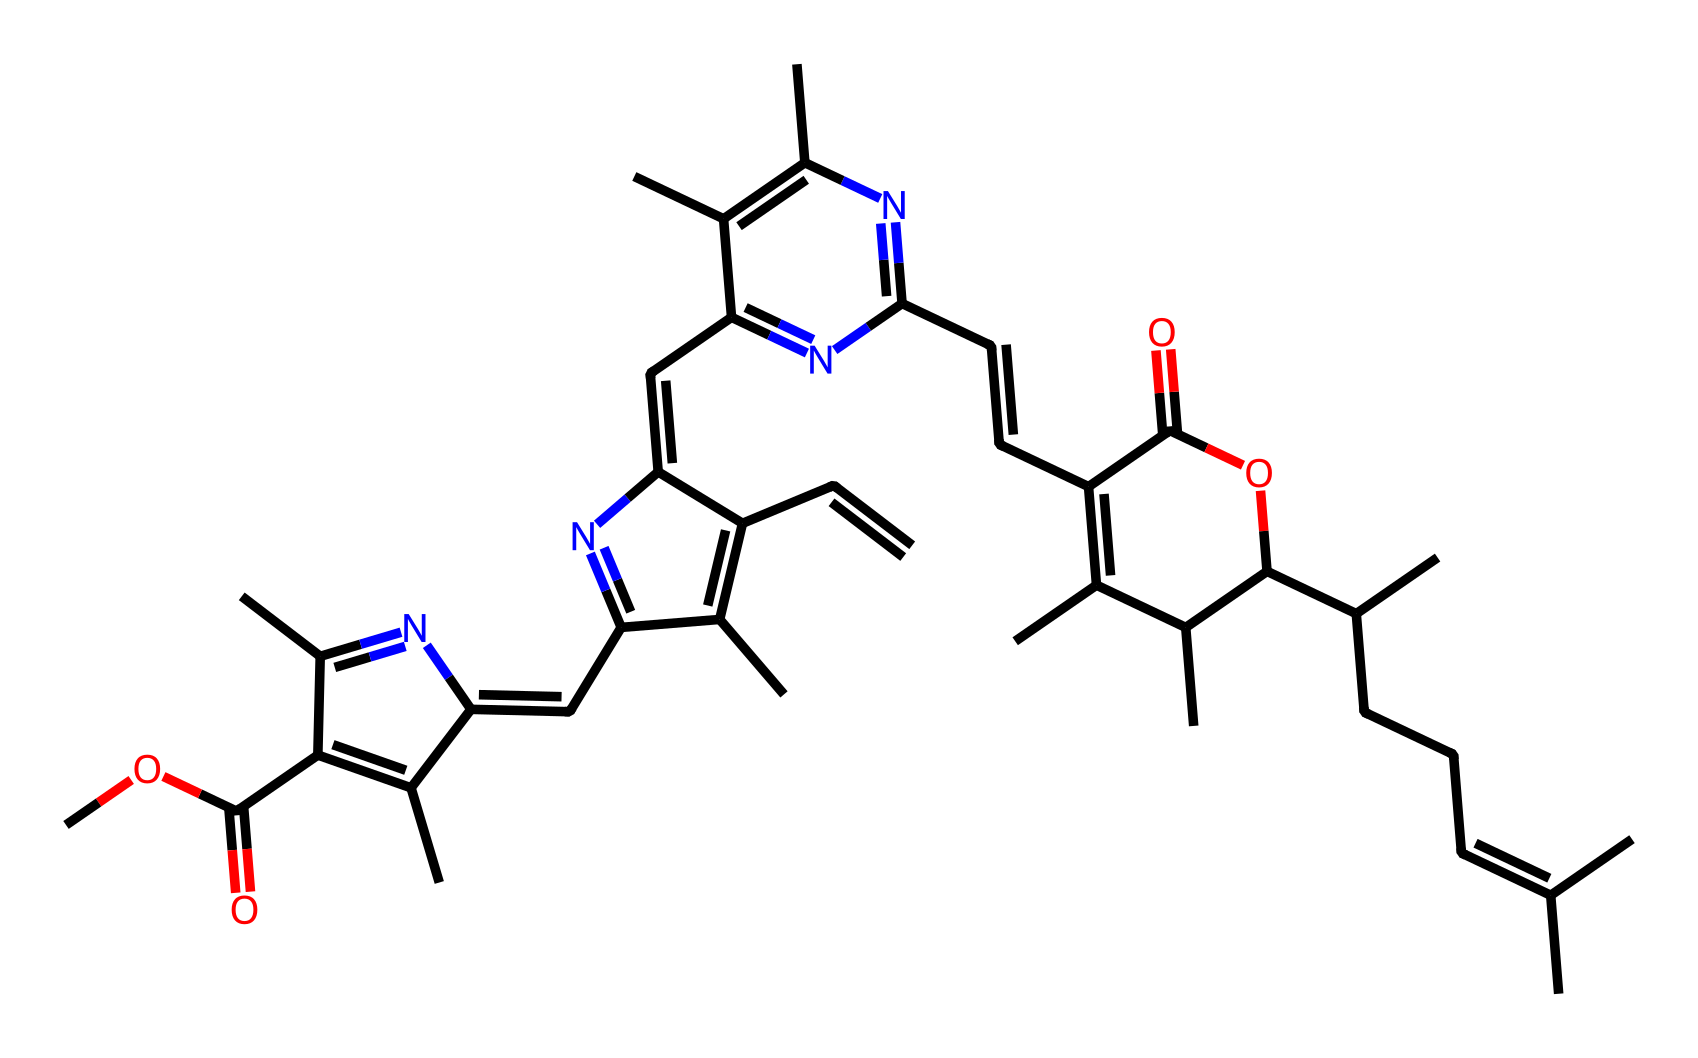How many carbon atoms are in the structure? By analyzing the SMILES representation, we can count the number of 'C' characters that represent carbon atoms. Each carbon atom in the structure signifies a point in the molecule, and in this case, a systematic count shows that there are 30 carbon atoms.
Answer: 30 What functional groups are present in this chemical? Looking at the structure derived from the SMILES, we can identify the functional groups by observing the atoms and their connections. Notably, there are ester groups (evidenced by the -OC(=O) linkage) and amine groups (indicated by the presence of nitrogen atoms attached to carbon chains).
Answer: ester, amine How many nitrogen atoms are in this molecule? By systematically reviewing the SMILES representation, we can identify and count the number of 'N' characters, each representing a nitrogen atom in the compound. In this molecule, there are 4 nitrogen atoms present.
Answer: 4 What is the type of organic compound represented by this SMILES? The structure suggests a porphyrin-like compound, a class of organic compounds characterized by a large, cyclic arrangement of carbon and nitrogen atoms. This specific structure aligns with the characteristics of chlorophyll.
Answer: porphyrin Which part of the chemical is responsible for light absorption? In chlorophyll molecules, the conjugated double bonds within the rings and the presence of a long hydrophobic tail are critical for absorbing light. These conjugated systems allow for electron delocalization, enhancing light absorption efficiency, especially in the visible range.
Answer: conjugated double bonds What does the presence of multiple nitrogen atoms indicate about this molecule? The multiple nitrogen atoms in the structure serve as ligands that coordinate with magnesium ions typically found in chlorophyll. This coordination is crucial for the stability of the chlorophyll structure and its functionality in photosynthesis.
Answer: coordination with magnesium 